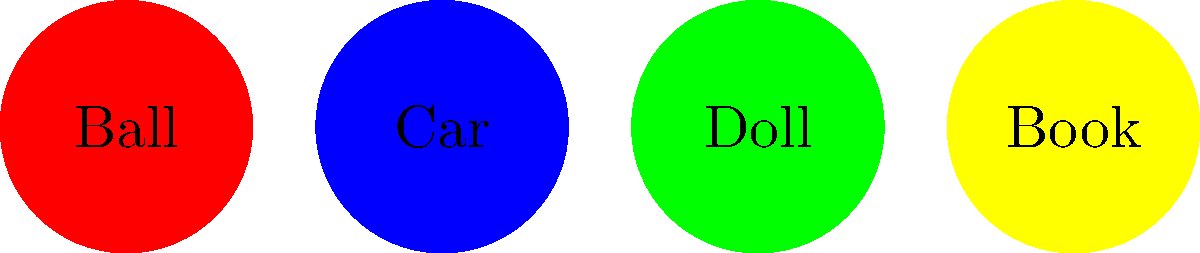Look at the colorful toys! Which one doesn't belong with the others? Let's look at each toy carefully:

1. Ball: This is a toy we can play with by throwing, bouncing, or rolling.
2. Car: We can push this toy and make it move on the ground.
3. Doll: We can pretend play with this toy, dressing it up or having tea parties.
4. Book: This is different from the others. We don't play with it like the other toys.

The book is used for reading and looking at pictures. It's not something we throw, push, or pretend with like the other toys. That's why the book doesn't belong in this group of toys.
Answer: Book 